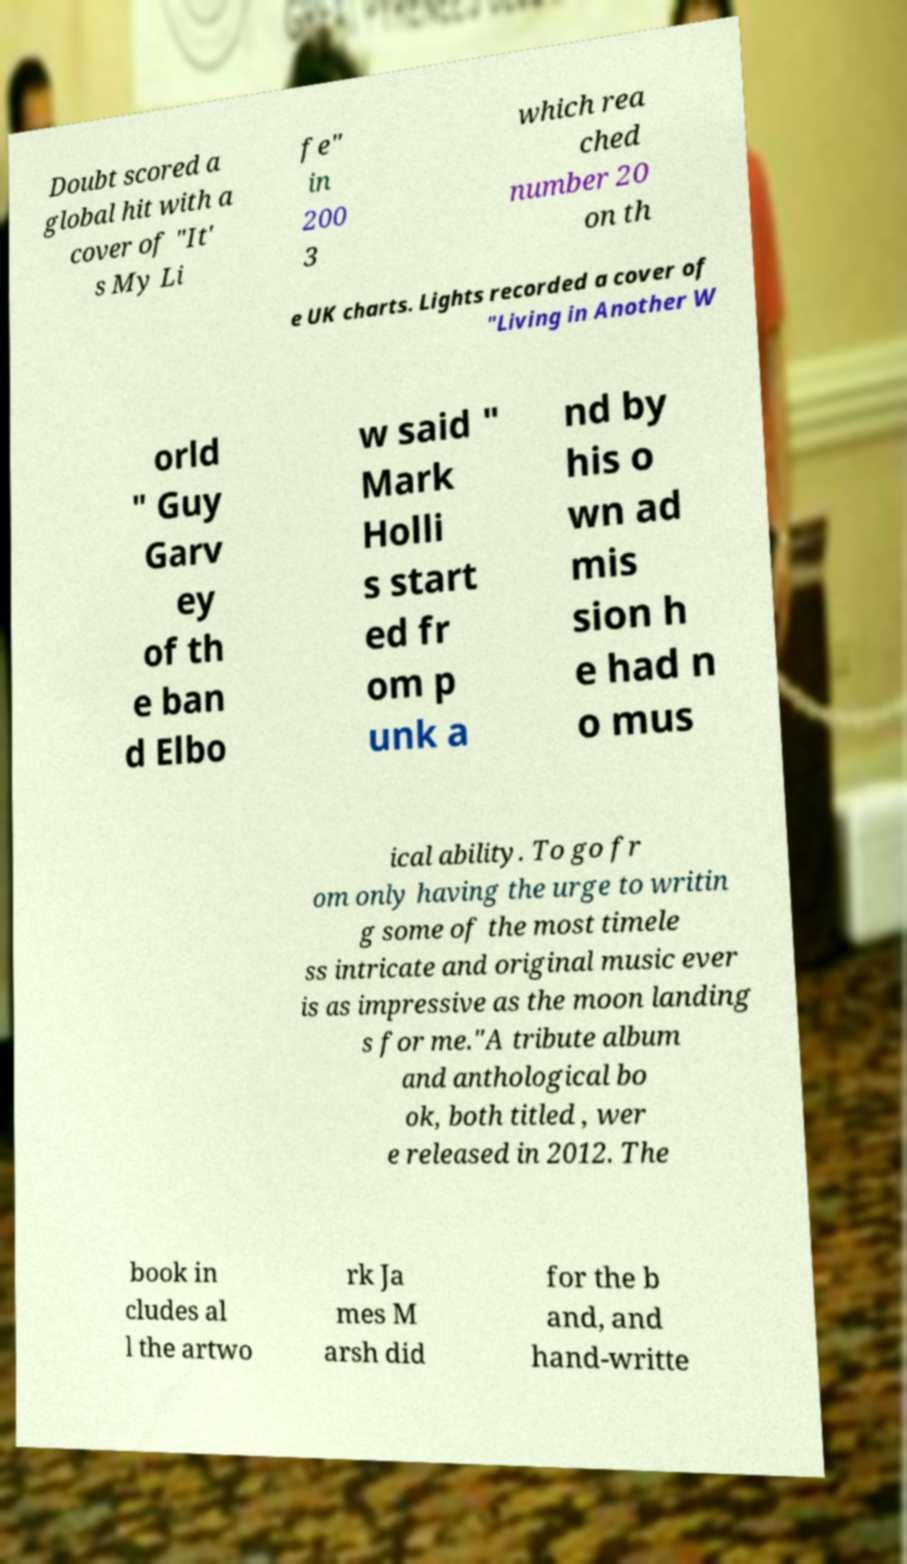For documentation purposes, I need the text within this image transcribed. Could you provide that? Doubt scored a global hit with a cover of "It' s My Li fe" in 200 3 which rea ched number 20 on th e UK charts. Lights recorded a cover of "Living in Another W orld " Guy Garv ey of th e ban d Elbo w said " Mark Holli s start ed fr om p unk a nd by his o wn ad mis sion h e had n o mus ical ability. To go fr om only having the urge to writin g some of the most timele ss intricate and original music ever is as impressive as the moon landing s for me."A tribute album and anthological bo ok, both titled , wer e released in 2012. The book in cludes al l the artwo rk Ja mes M arsh did for the b and, and hand-writte 